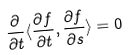<formula> <loc_0><loc_0><loc_500><loc_500>\frac { \partial } { \partial t } \langle \frac { \partial f } { \partial t } , \frac { \partial f } { \partial s } \rangle = 0</formula> 